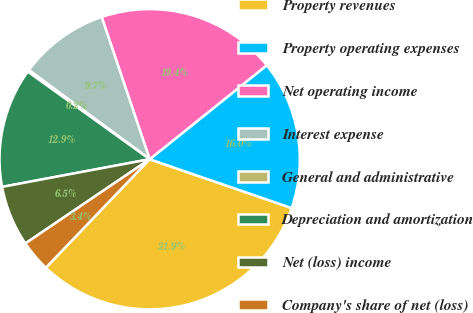Convert chart to OTSL. <chart><loc_0><loc_0><loc_500><loc_500><pie_chart><fcel>Property revenues<fcel>Property operating expenses<fcel>Net operating income<fcel>Interest expense<fcel>General and administrative<fcel>Depreciation and amortization<fcel>Net (loss) income<fcel>Company's share of net (loss)<nl><fcel>31.88%<fcel>16.04%<fcel>19.42%<fcel>9.7%<fcel>0.2%<fcel>12.87%<fcel>6.53%<fcel>3.37%<nl></chart> 